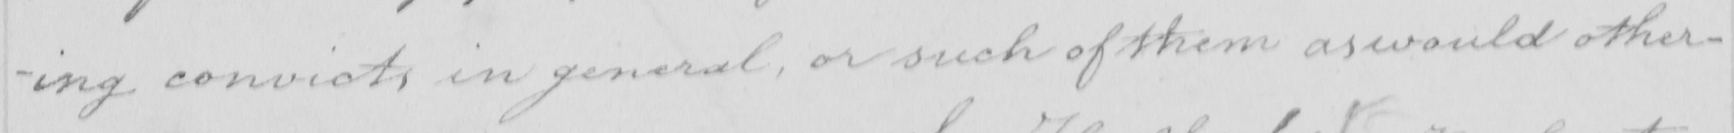What does this handwritten line say? -ing convicts in general , or such of them as would other- 